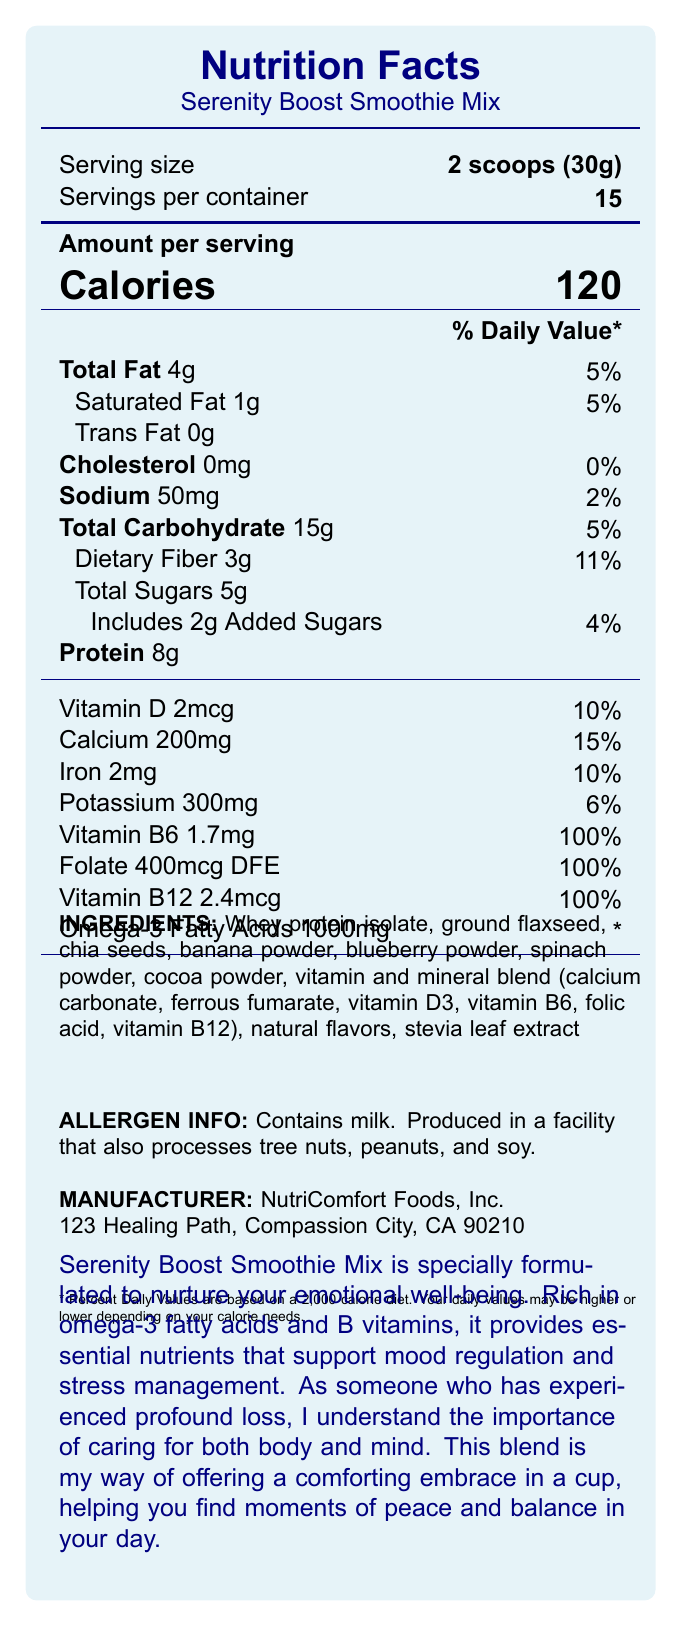what is the serving size? The document states that the serving size is 2 scoops, which equals 30 grams.
Answer: 2 scoops (30g) how many servings are there per container? According to the document, there are 15 servings per container.
Answer: 15 how many calories are in one serving? The document lists the amount of calories per serving as 120.
Answer: 120 what is the total fat content per serving? The document shows that the total fat content per serving is 4 grams, which constitutes 5% of the daily value.
Answer: 4g how much dietary fiber is in one serving? The document mentions that each serving contains 3 grams of dietary fiber.
Answer: 3g which ingredient provides omega-3 fatty acids? A. Chia seeds B. Banana powder C. Whey protein isolate D. Stevia leaf extract The document lists chia seeds as one of the ingredients, which are known for their high omega-3 fatty acid content.
Answer: A. Chia seeds what percentage of the daily value of calcium does one serving provide? Based on the document, one serving provides 15% of the daily value for calcium.
Answer: 15% does this product contain any added sugars? The document states that there are 2 grams of added sugars per serving.
Answer: Yes which vitamins are provided at 100% of the daily value? A. Vitamin D B. Vitamin B6 C. Vitamin C D. Vitamin B12 E. Folate The document lists Vitamin B6, Vitamin B12, and Folate as providing 100% of the daily value per serving.
Answer: B, D, E how much cholesterol is in a serving of Serenity Boost Smoothie Mix? The document indicates that there is 0mg of cholesterol per serving.
Answer: 0mg are there any allergens in this product? The document states that the product contains milk and is produced in a facility that also processes tree nuts, peanuts, and soy.
Answer: Yes where is the manufacturer located? The document provides the manufacturer's address as 123 Healing Path, Compassion City, CA 90210.
Answer: 123 Healing Path, Compassion City, CA 90210 how does this smoothie mix support emotional well-being? The document specifies that the mix is rich in omega-3 fatty acids and B vitamins, which support mood regulation and stress management.
Answer: Rich in omega-3 fatty acids and B vitamins what types of fats are found in the smoothie mix? A. Saturated Fat B. Unsaturated Fat C. Trans Fat The document mentions both saturated fat (1g) and trans fat (0g).
Answer: A, C how many grams of protein are in a serving? The document shows that there are 8 grams of protein per serving.
Answer: 8g is the product free from added sugars? The document indicates that there are 2 grams of added sugars per serving, so the product is not free from added sugars.
Answer: No can we determine the exact amount of vitamin C in the smoothie mix? The document does not provide any data regarding the vitamin C content.
Answer: Not enough information summarize the main benefits of the Serenity Boost Smoothie Mix. The document describes the main benefits as support for emotional well-being through omega-3 fatty acids and B vitamins, and provides detailed nutritional content that supports mood regulation, stress management, and a balanced diet.
Answer: Serenity Boost Smoothie Mix is designed to support emotional well-being with its rich content of omega-3 fatty acids and B vitamins. It provides essential nutrients for mood regulation and stress management. Each serving offers a balanced nutritional profile, including protein, dietary fiber, and various vitamins and minerals to foster both physical and emotional health. is the product suitable for someone with a peanut allergy? Although the document states that the product does not contain peanuts, it is produced in a facility that processes peanuts. This information might be concerning for someone with a severe peanut allergy, but it is not conclusive.
Answer: Not enough information 